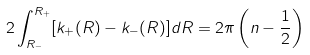<formula> <loc_0><loc_0><loc_500><loc_500>2 \int _ { R _ { - } } ^ { R _ { + } } [ k _ { + } ( R ) - k _ { - } ( R ) ] d R = 2 \pi \left ( n - \frac { 1 } { 2 } \right ) \,</formula> 